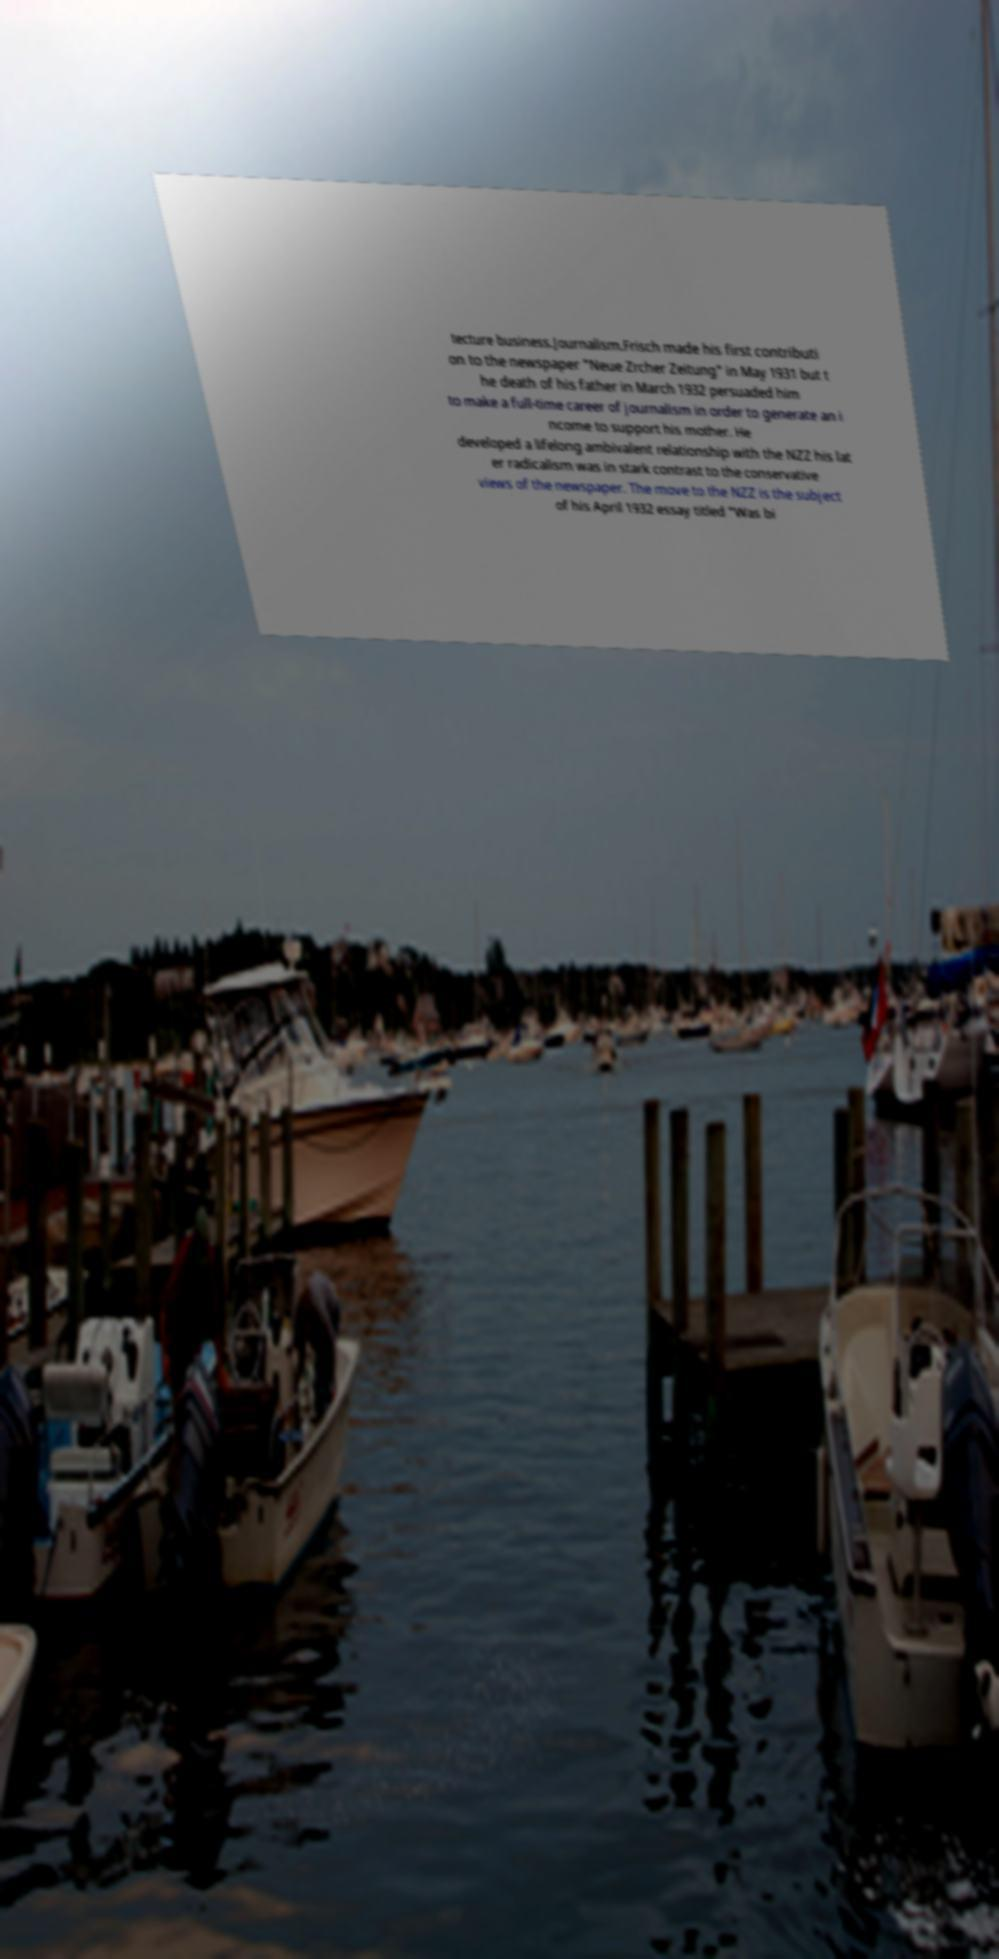Can you accurately transcribe the text from the provided image for me? tecture business.Journalism.Frisch made his first contributi on to the newspaper "Neue Zrcher Zeitung" in May 1931 but t he death of his father in March 1932 persuaded him to make a full-time career of journalism in order to generate an i ncome to support his mother. He developed a lifelong ambivalent relationship with the NZZ his lat er radicalism was in stark contrast to the conservative views of the newspaper. The move to the NZZ is the subject of his April 1932 essay titled "Was bi 